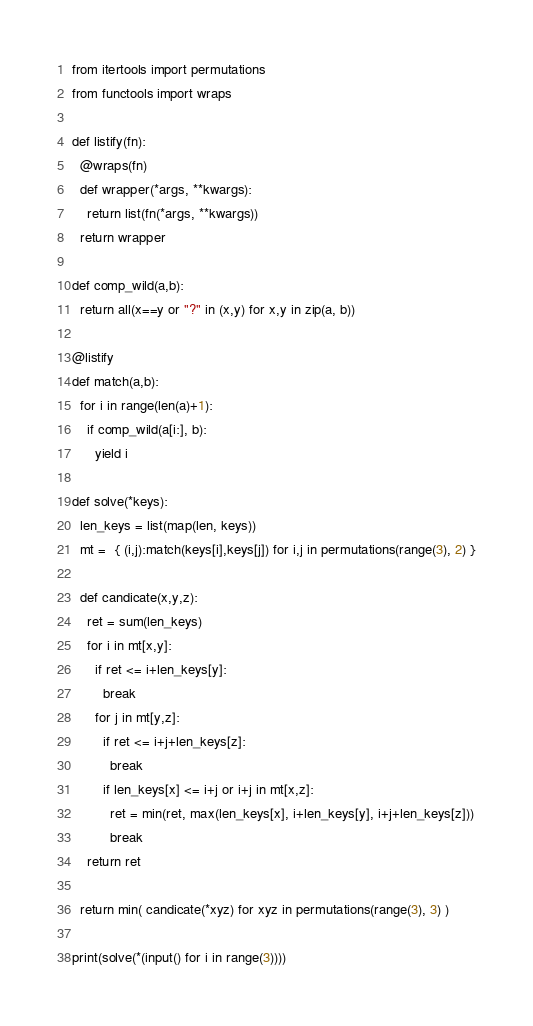Convert code to text. <code><loc_0><loc_0><loc_500><loc_500><_Python_>from itertools import permutations
from functools import wraps

def listify(fn):
  @wraps(fn)
  def wrapper(*args, **kwargs):
    return list(fn(*args, **kwargs))
  return wrapper

def comp_wild(a,b):
  return all(x==y or "?" in (x,y) for x,y in zip(a, b))
  
@listify
def match(a,b):
  for i in range(len(a)+1):
    if comp_wild(a[i:], b):
      yield i

def solve(*keys):
  len_keys = list(map(len, keys))
  mt =  { (i,j):match(keys[i],keys[j]) for i,j in permutations(range(3), 2) }
  
  def candicate(x,y,z):
    ret = sum(len_keys)
    for i in mt[x,y]:
      if ret <= i+len_keys[y]:
        break
      for j in mt[y,z]:
        if ret <= i+j+len_keys[z]:
          break
        if len_keys[x] <= i+j or i+j in mt[x,z]:
          ret = min(ret, max(len_keys[x], i+len_keys[y], i+j+len_keys[z]))
          break
    return ret
  
  return min( candicate(*xyz) for xyz in permutations(range(3), 3) )

print(solve(*(input() for i in range(3))))
</code> 